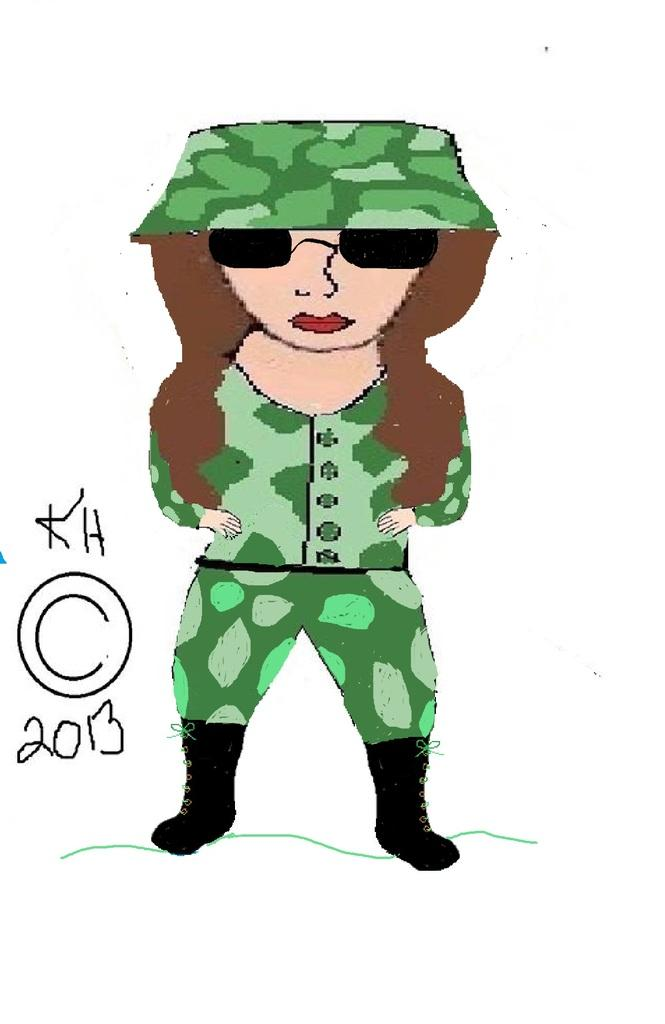What style is the image in? The image is a cartoon. Who is depicted in the cartoon? The cartoon depicts a woman. What else can be seen in the image besides the woman? There is text and a symbol visible in the image. What color is the background of the image? The background of the image is white. How many boats are in the image? There are no boats present in the image. 